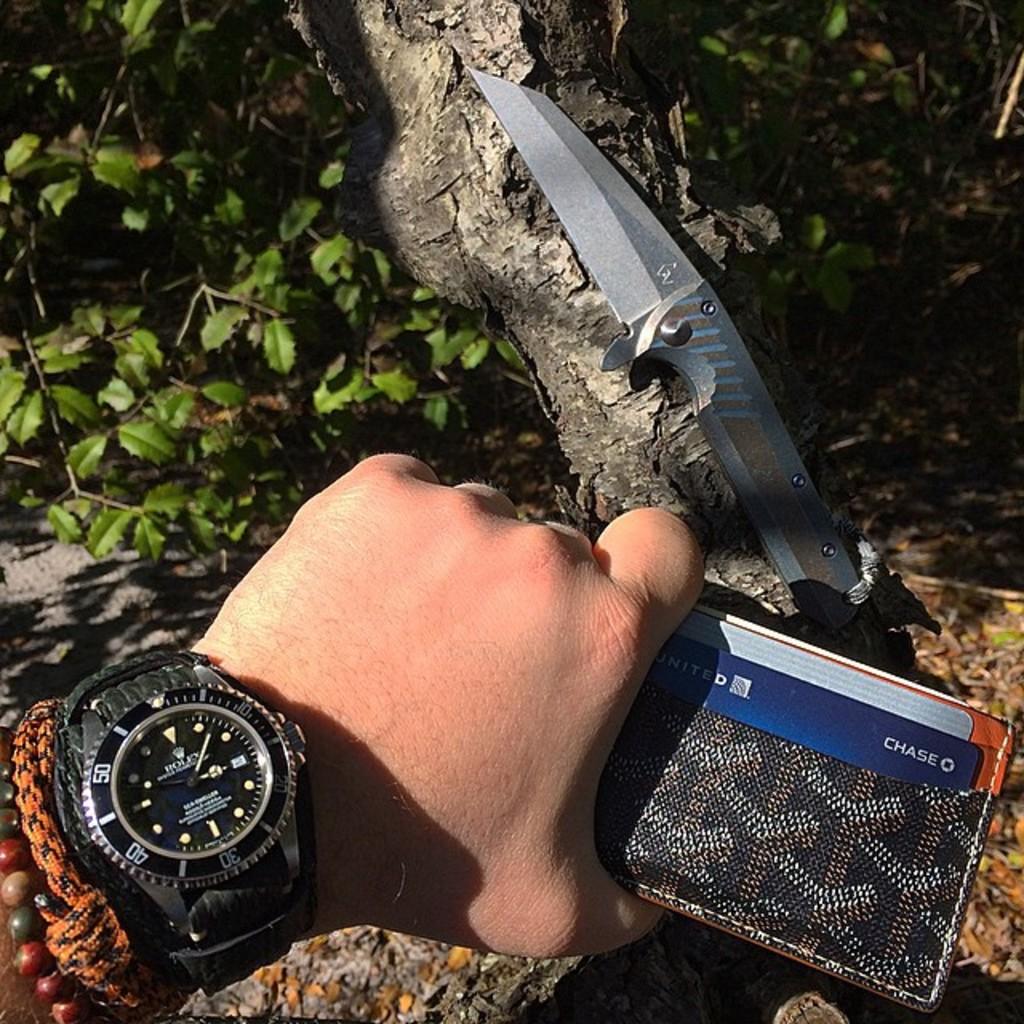What number is shown?
Make the answer very short. 50. What bank issued the blue credit card?
Provide a short and direct response. Chase. 